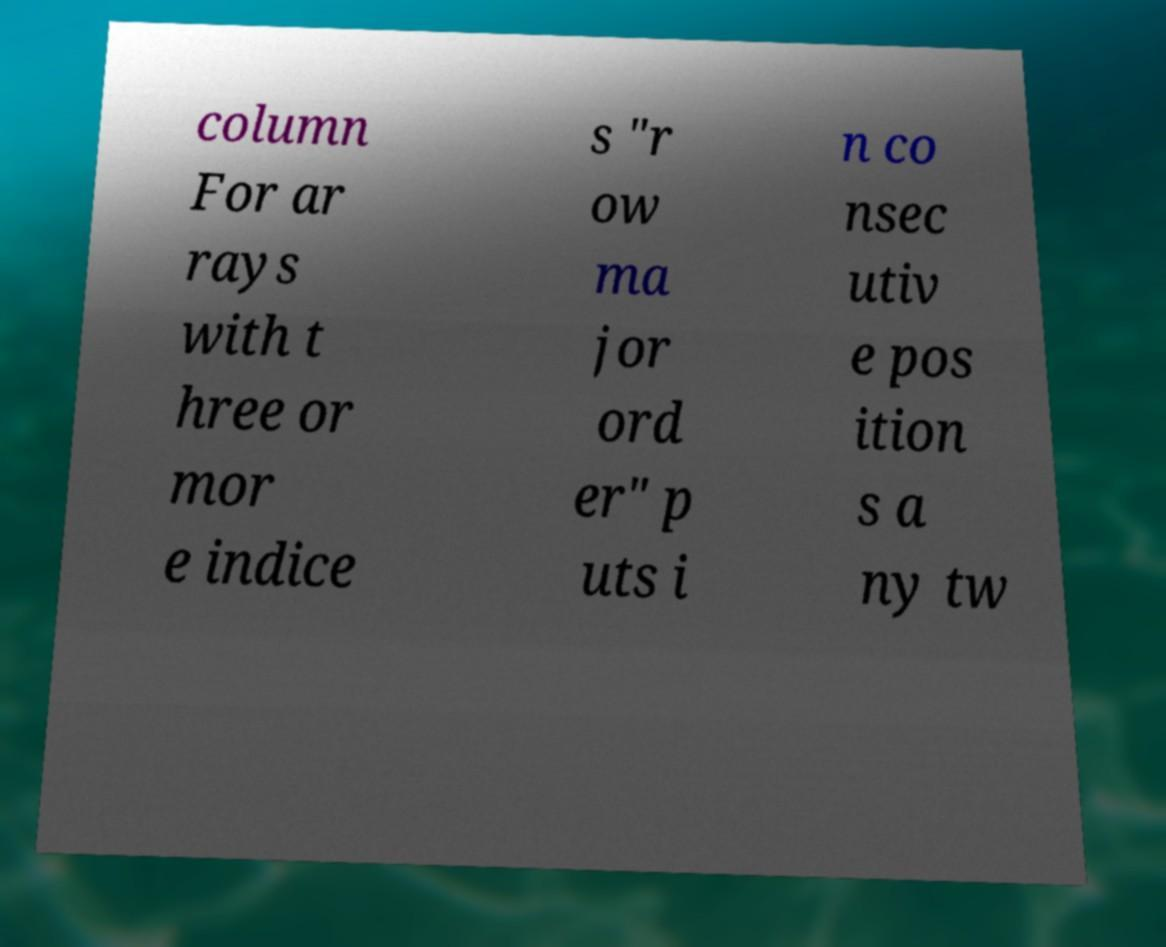Can you read and provide the text displayed in the image?This photo seems to have some interesting text. Can you extract and type it out for me? column For ar rays with t hree or mor e indice s "r ow ma jor ord er" p uts i n co nsec utiv e pos ition s a ny tw 